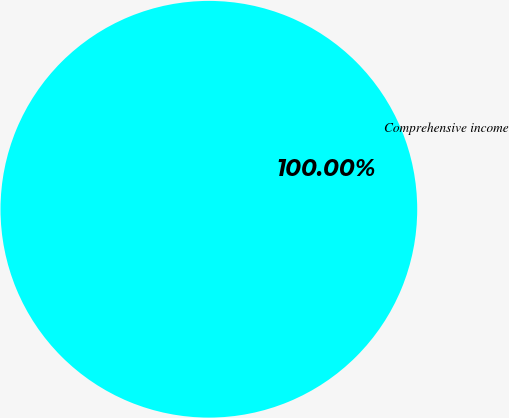Convert chart. <chart><loc_0><loc_0><loc_500><loc_500><pie_chart><fcel>Comprehensive income<nl><fcel>100.0%<nl></chart> 